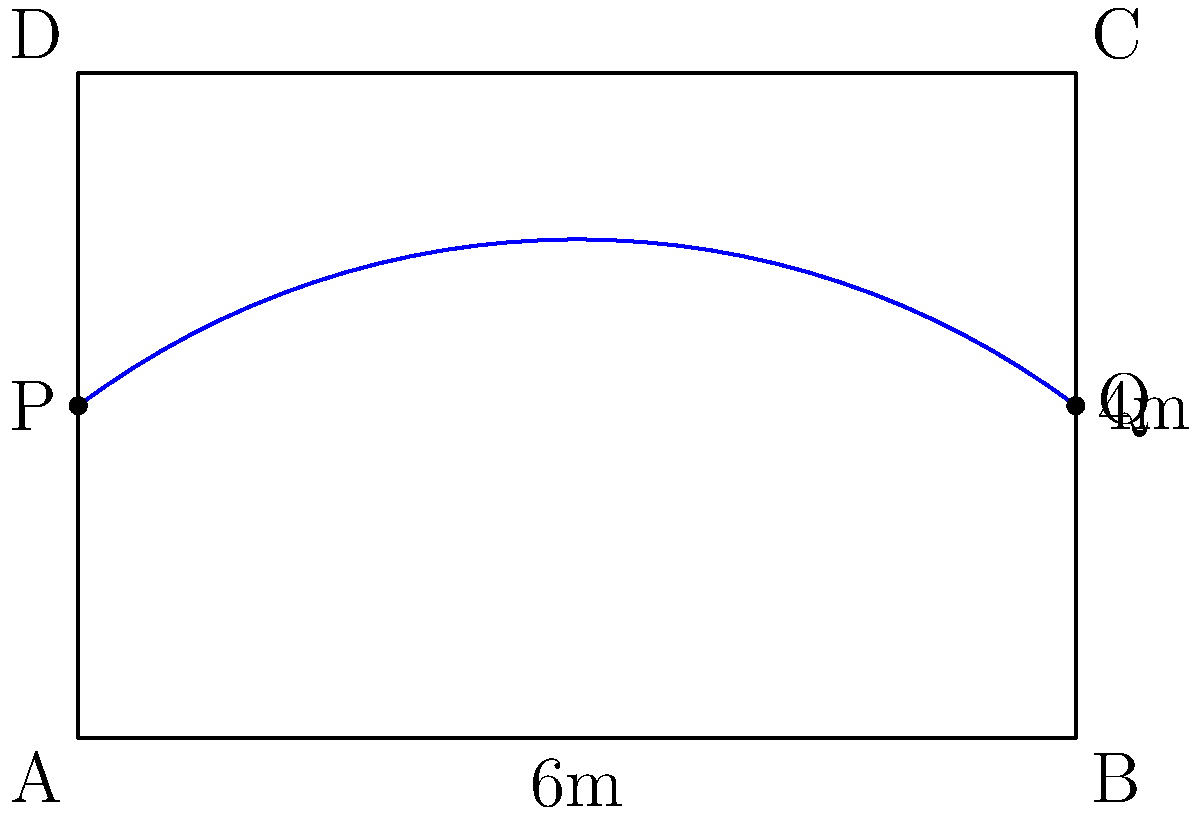A traditional Japanese garden pond has a rectangular shape with a curved edge along one side, as shown in the diagram. The straight sides of the pond measure 6 meters and 4 meters. If the curved edge can be approximated as a semicircle, calculate the perimeter of the pond to the nearest tenth of a meter. To calculate the perimeter of the pond, we need to add the lengths of the straight sides and the curved edge. Let's break it down step-by-step:

1. Calculate the sum of the straight sides:
   $$6 \text{ m} + 6 \text{ m} + 4 \text{ m} = 16 \text{ m}$$

2. Calculate the length of the curved edge:
   - The curved edge is approximated as a semicircle
   - The diameter of this semicircle is the width of the pond, which is 4 meters
   - The formula for the length of a semicircle is $\frac{\pi r}{2}$, where $r$ is the radius
   - The radius is half the diameter: $r = 4 \text{ m} \div 2 = 2 \text{ m}$
   - Length of the curved edge = $\frac{\pi \cdot 2 \text{ m}}{2} = \pi \text{ m}$

3. Calculate the total perimeter:
   $$\text{Perimeter} = 16 \text{ m} + \pi \text{ m} \approx 16 \text{ m} + 3.14159 \text{ m} = 19.14159 \text{ m}$$

4. Round to the nearest tenth:
   $$19.14159 \text{ m} \approx 19.1 \text{ m}$$

Therefore, the perimeter of the Japanese garden pond is approximately 19.1 meters.
Answer: 19.1 m 